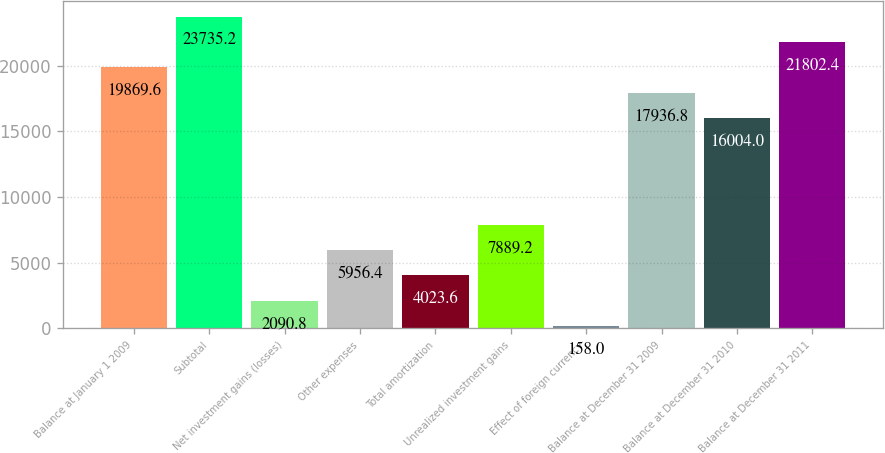Convert chart to OTSL. <chart><loc_0><loc_0><loc_500><loc_500><bar_chart><fcel>Balance at January 1 2009<fcel>Subtotal<fcel>Net investment gains (losses)<fcel>Other expenses<fcel>Total amortization<fcel>Unrealized investment gains<fcel>Effect of foreign currency<fcel>Balance at December 31 2009<fcel>Balance at December 31 2010<fcel>Balance at December 31 2011<nl><fcel>19869.6<fcel>23735.2<fcel>2090.8<fcel>5956.4<fcel>4023.6<fcel>7889.2<fcel>158<fcel>17936.8<fcel>16004<fcel>21802.4<nl></chart> 